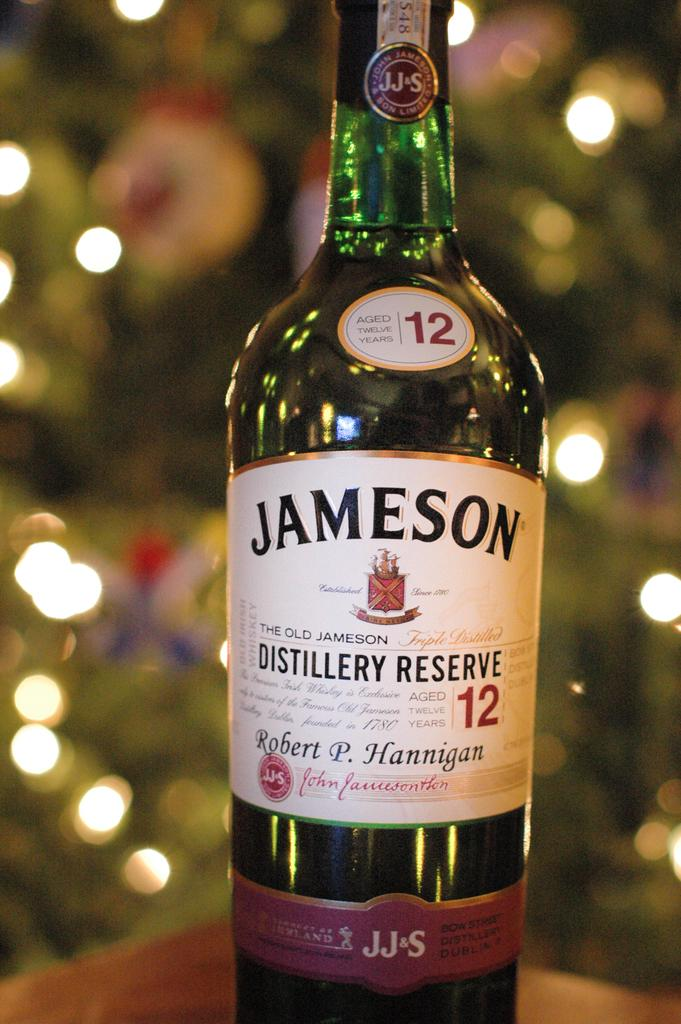<image>
Describe the image concisely. the word Jameson that is on a bottle 